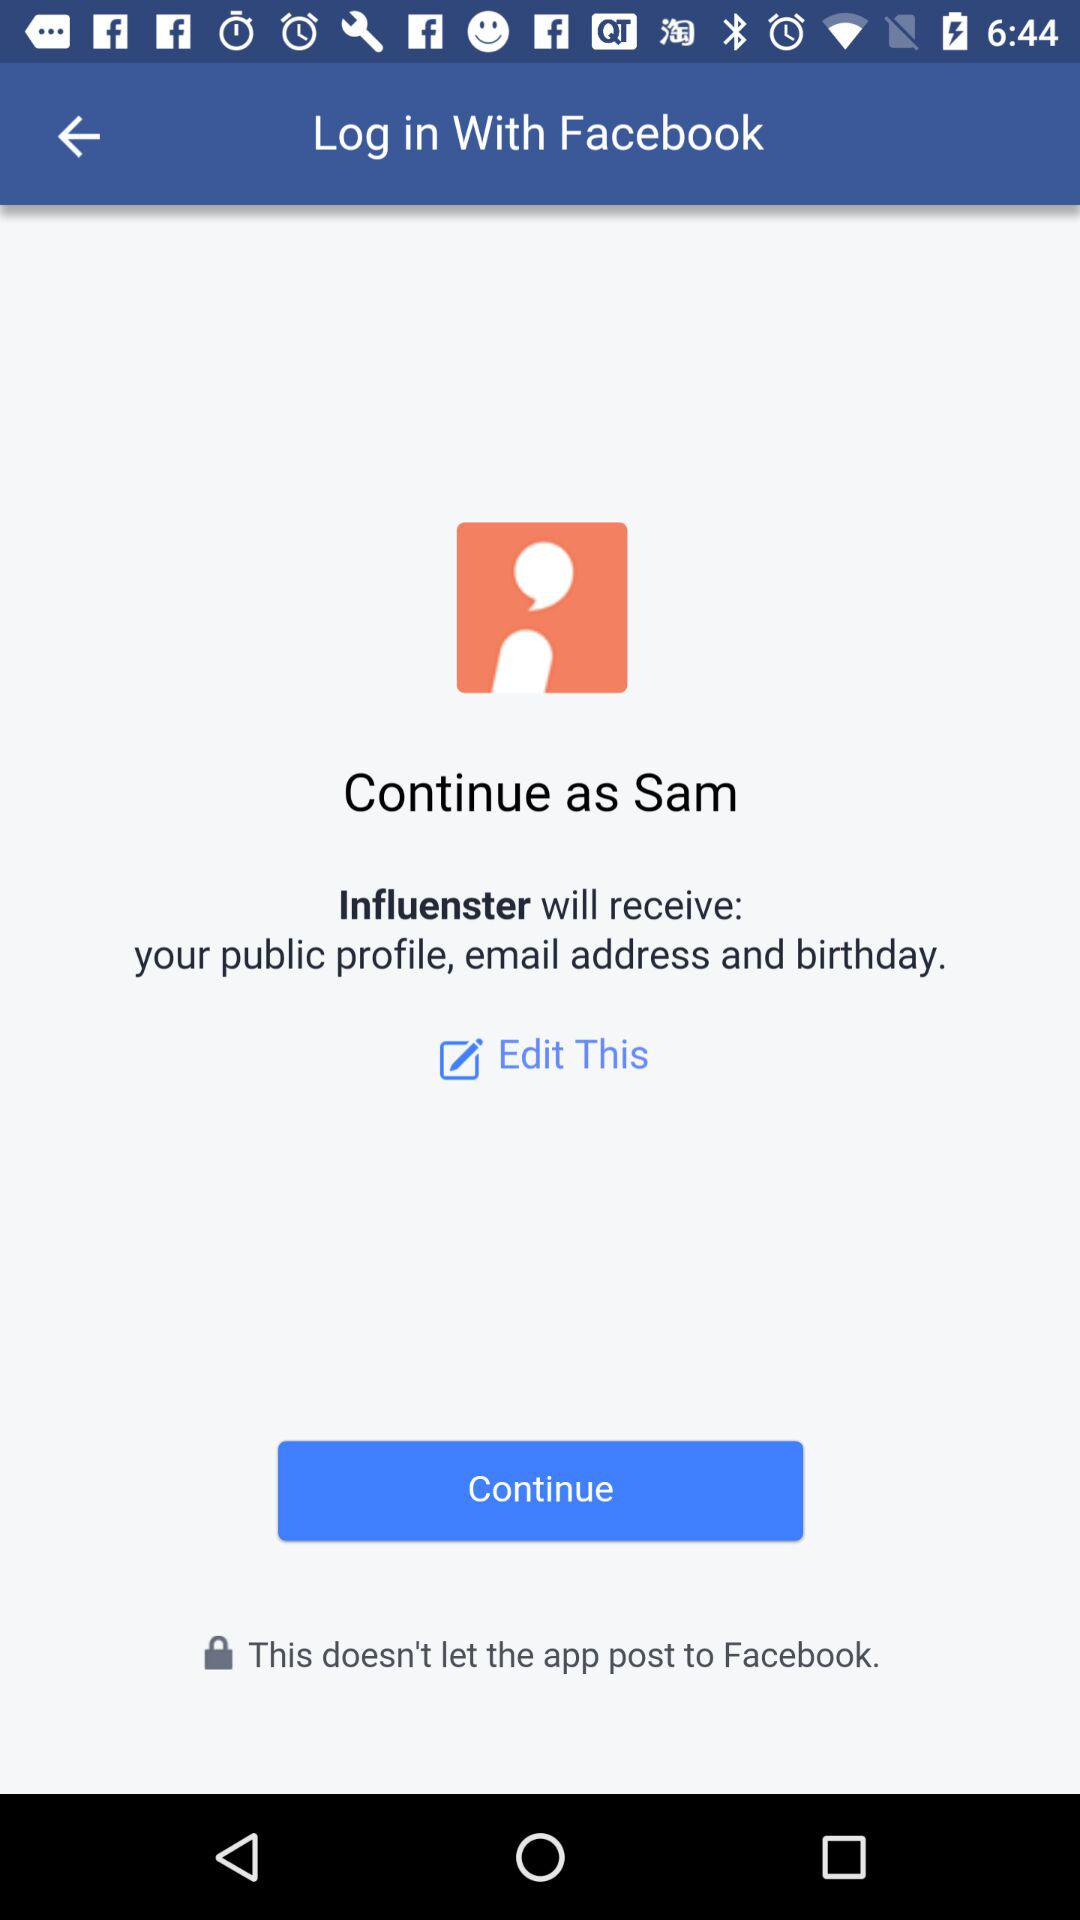Which option is selected?
When the provided information is insufficient, respond with <no answer>. <no answer> 